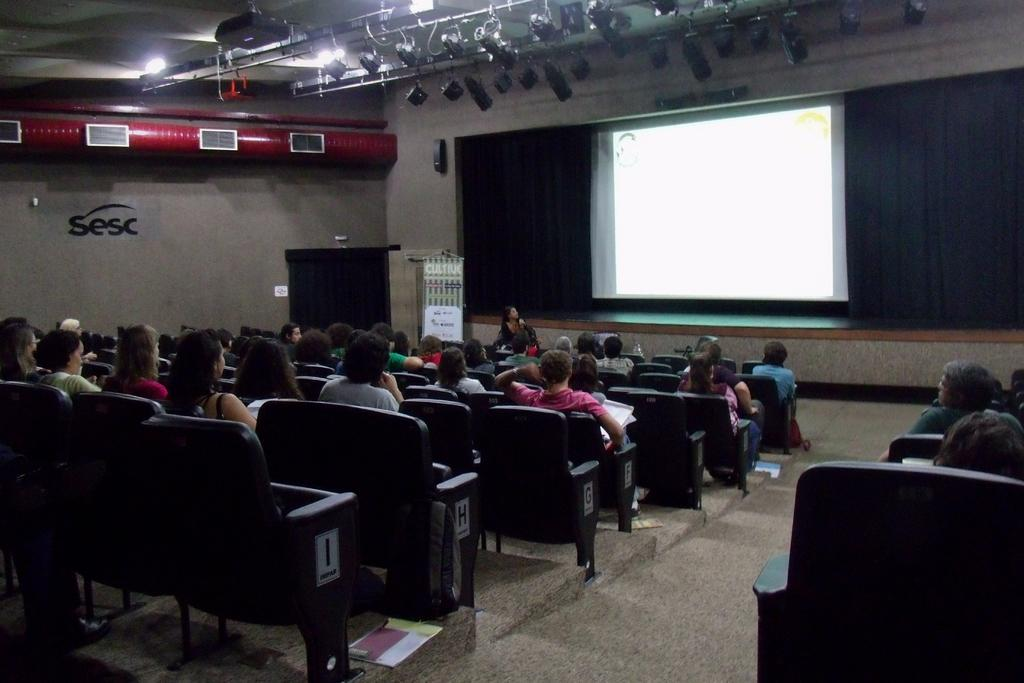How many people are in the image? There is a group of people in the image. What are the people in the image doing? The people are sitting in chairs. What can be seen in the background of the image? There are lights, a screen, and a podium in the background of the image. What type of poison is being used by the people in the image? There is no poison present in the image; the people are simply sitting in chairs. 